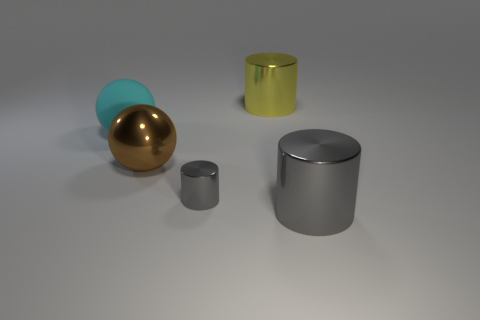Subtract all gray cylinders. How many cylinders are left? 1 Add 1 metallic cylinders. How many objects exist? 6 Subtract all brown spheres. How many spheres are left? 1 Add 4 big metal balls. How many big metal balls exist? 5 Subtract 0 yellow cubes. How many objects are left? 5 Subtract all cylinders. How many objects are left? 2 Subtract all green cylinders. Subtract all yellow blocks. How many cylinders are left? 3 Subtract all red blocks. How many cyan spheres are left? 1 Subtract all large purple shiny cylinders. Subtract all big brown shiny objects. How many objects are left? 4 Add 4 large cyan matte balls. How many large cyan matte balls are left? 5 